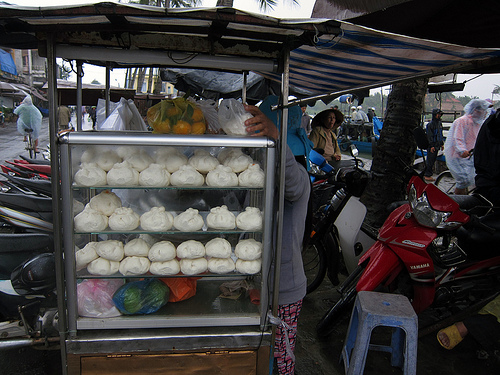<image>
Is the dough in the cooler? Yes. The dough is contained within or inside the cooler, showing a containment relationship. Is there a loaf to the left of the stool? Yes. From this viewpoint, the loaf is positioned to the left side relative to the stool. 